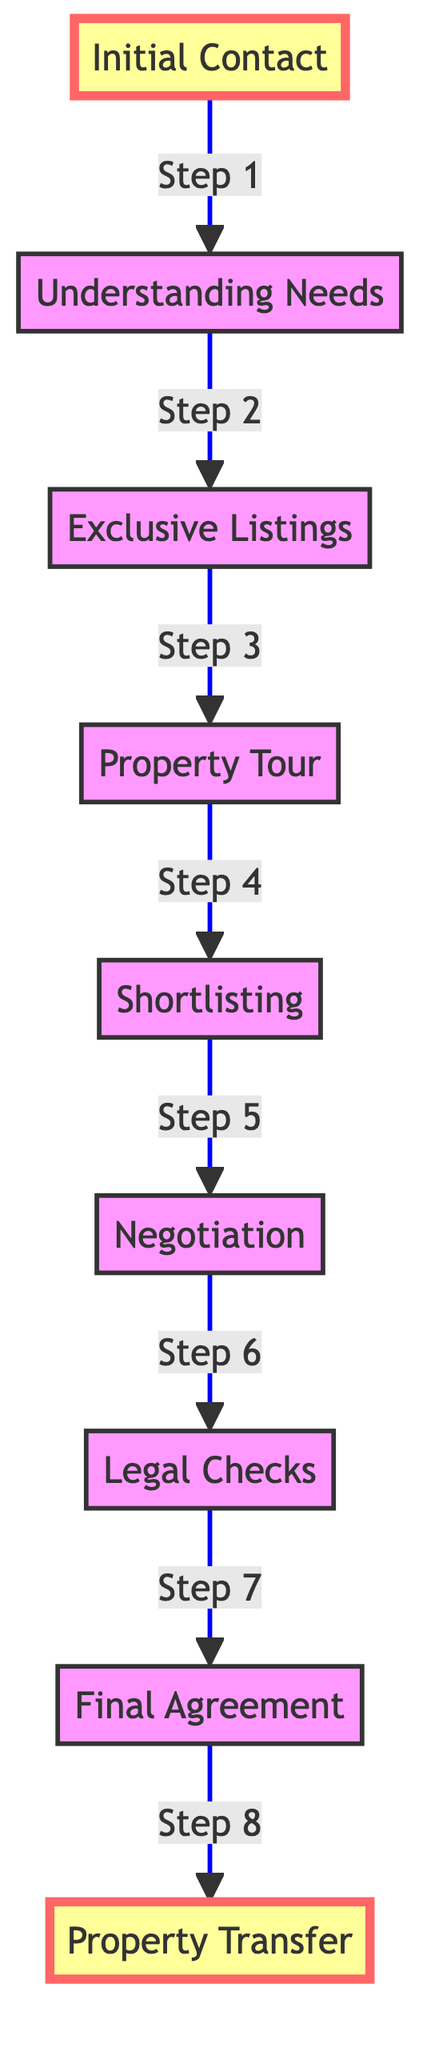What is the first step in the property acquisition journey? The diagram starts from the node labeled 'Initial Contact,' which indicates it is the first step in the client journey.
Answer: Initial Contact How many total steps are there in the diagram? By counting each node that represents a step, there are eight total steps in the client journey from initial contact to property transfer.
Answer: Eight Which step comes after 'Shortlisting'? In the sequence provided by the flowchart, 'Negotiation' is directly connected to 'Shortlisting' as the next step in the client journey.
Answer: Negotiation What is the last milestone in the property acquisition process? The last milestone in the diagram is the node labeled 'Property Transfer,' marking the final agreement in the journey.
Answer: Property Transfer How many milestone markers are present in the diagram? There are two milestone markers shown in the diagram, 'Initial Contact' and 'Property Transfer,' at the beginning and end of the journey respectively.
Answer: Two What is the relationship between 'Understanding Needs' and 'Exclusive Listings'? 'Understanding Needs' leads directly to 'Exclusive Listings,' indicating that this step precedes and is essential for moving on to viewing listings.
Answer: Leads to What are the two main milestone markers labeled in the diagram? The milestones are labeled 'Initial Contact' and 'Property Transfer,' marking critical points within the overall acquisition process.
Answer: Initial Contact and Property Transfer Which step involves negotiations? Referring to the flowchart, 'Negotiation' is the specific step dedicated to discussions surrounding terms before finalizing the purchase.
Answer: Negotiation What is the step immediately before 'Final Agreement'? The step that directly precedes 'Final Agreement' in the depicted flowchart is 'Legal Checks,' which is necessary before reaching the final agreement.
Answer: Legal Checks 